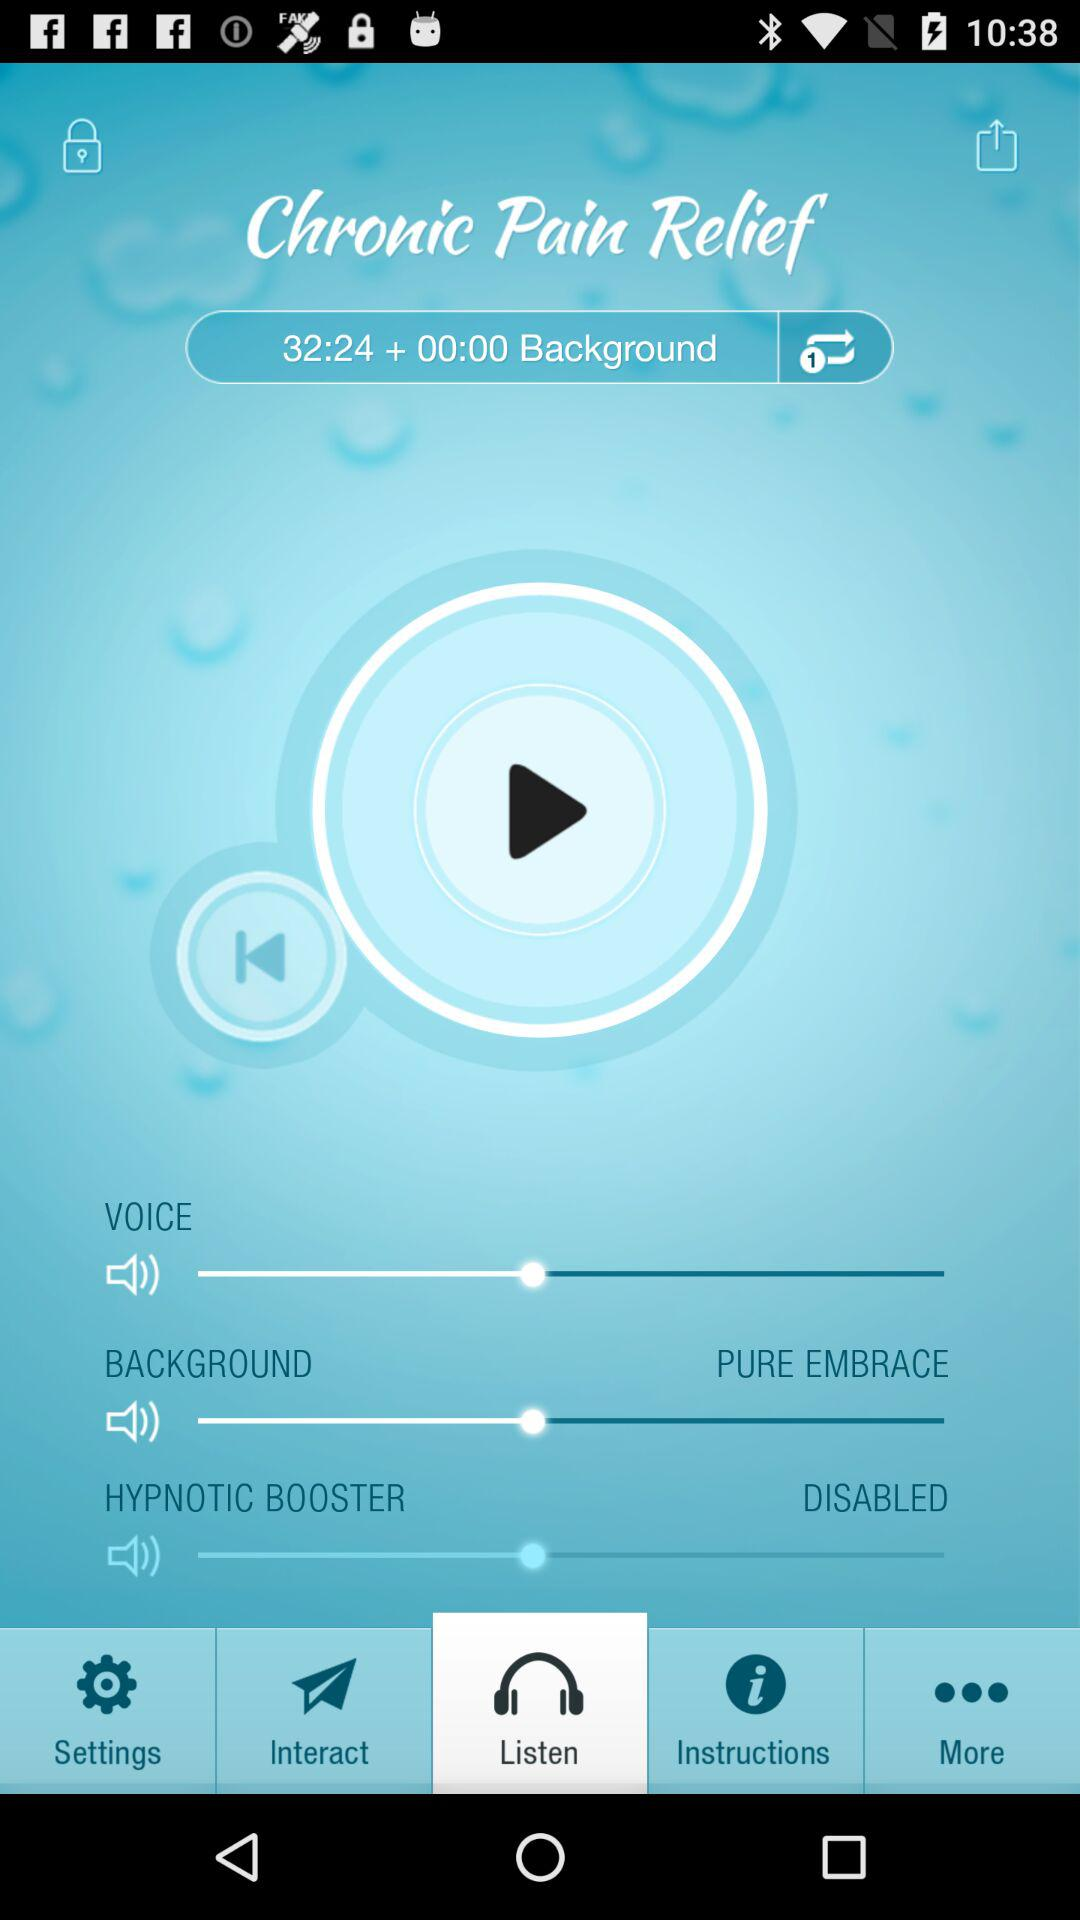Which background is chosen? The chosen background is pure embrace. 